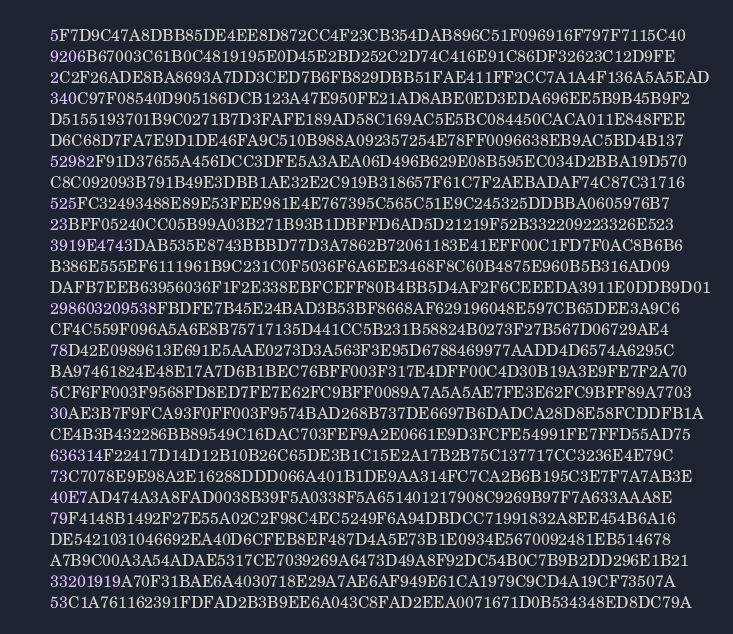<code> <loc_0><loc_0><loc_500><loc_500><_Pascal_>      5F7D9C47A8DBB85DE4EE8D872CC4F23CB354DAB896C51F096916F797F7115C40
      9206B67003C61B0C4819195E0D45E2BD252C2D74C416E91C86DF32623C12D9FE
      2C2F26ADE8BA8693A7DD3CED7B6FB829DBB51FAE411FF2CC7A1A4F136A5A5EAD
      340C97F08540D905186DCB123A47E950FE21AD8ABE0ED3EDA696EE5B9B45B9F2
      D5155193701B9C0271B7D3FAFE189AD58C169AC5E5BC084450CACA011E848FEE
      D6C68D7FA7E9D1DE46FA9C510B988A092357254E78FF0096638EB9AC5BD4B137
      52982F91D37655A456DCC3DFE5A3AEA06D496B629E08B595EC034D2BBA19D570
      C8C092093B791B49E3DBB1AE32E2C919B318657F61C7F2AEBADAF74C87C31716
      525FC32493488E89E53FEE981E4E767395C565C51E9C245325DDBBA0605976B7
      23BFF05240CC05B99A03B271B93B1DBFFD6AD5D21219F52B332209223326E523
      3919E4743DAB535E8743BBBD77D3A7862B72061183E41EFF00C1FD7F0AC8B6B6
      B386E555EF6111961B9C231C0F5036F6A6EE3468F8C60B4875E960B5B316AD09
      DAFB7EEB63956036F1F2E338EBFCEFF80B4BB5D4AF2F6CEEEDA3911E0DDB9D01
      298603209538FBDFE7B45E24BAD3B53BF8668AF629196048E597CB65DEE3A9C6
      CF4C559F096A5A6E8B75717135D441CC5B231B58824B0273F27B567D06729AE4
      78D42E0989613E691E5AAE0273D3A563F3E95D6788469977AADD4D6574A6295C
      BA97461824E48E17A7D6B1BEC76BFF003F317E4DFF00C4D30B19A3E9FE7F2A70
      5CF6FF003F9568FD8ED7FE7E62FC9BFF0089A7A5A5AE7FE3E62FC9BFF89A7703
      30AE3B7F9FCA93F0FF003F9574BAD268B737DE6697B6DADCA28D8E58FCDDFB1A
      CE4B3B432286BB89549C16DAC703FEF9A2E0661E9D3FCFE54991FE7FFD55AD75
      636314F22417D14D12B10B26C65DE3B1C15E2A17B2B75C137717CC3236E4E79C
      73C7078E9E98A2E16288DDD066A401B1DE9AA314FC7CA2B6B195C3E7F7A7AB3E
      40E7AD474A3A8FAD0038B39F5A0338F5A651401217908C9269B97F7A633AAA8E
      79F4148B1492F27E55A02C2F98C4EC5249F6A94DBDCC71991832A8EE454B6A16
      DE5421031046692EA40D6CFEB8EF487D4A5E73B1E0934E5670092481EB514678
      A7B9C00A3A54ADAE5317CE7039269A6473D49A8F92DC54B0C7B9B2DD296E1B21
      33201919A70F31BAE6A4030718E29A7AE6AF949E61CA1979C9CD4A19CF73507A
      53C1A761162391FDFAD2B3B9EE6A043C8FAD2EEA0071671D0B534348ED8DC79A</code> 